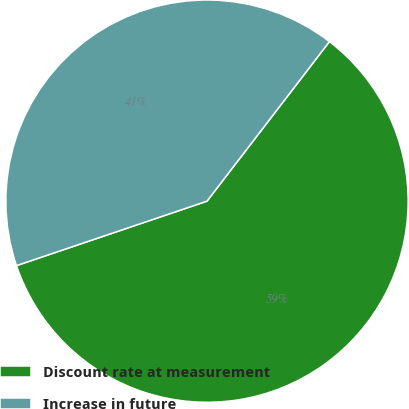Convert chart to OTSL. <chart><loc_0><loc_0><loc_500><loc_500><pie_chart><fcel>Discount rate at measurement<fcel>Increase in future<nl><fcel>59.39%<fcel>40.61%<nl></chart> 